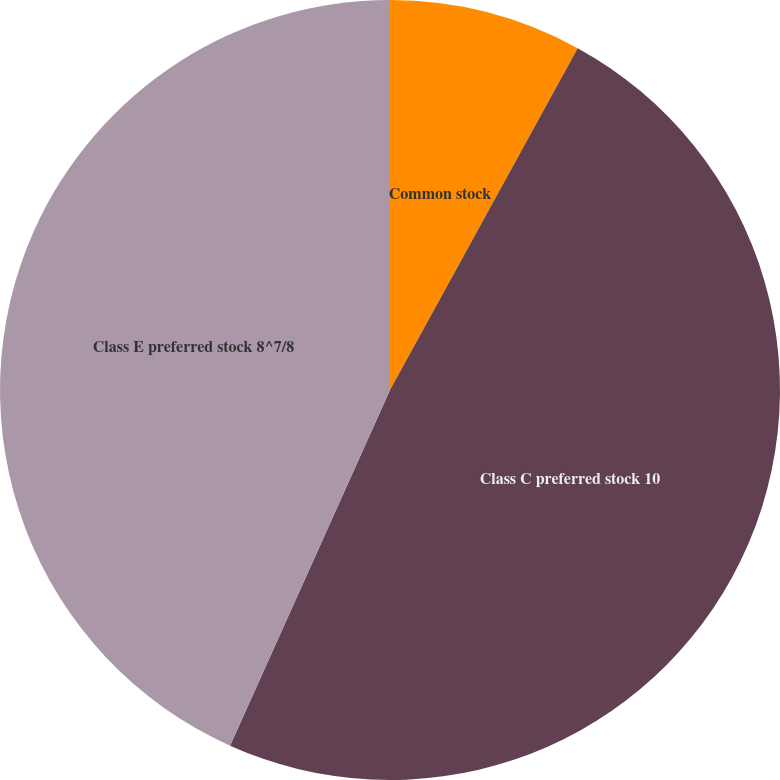Convert chart to OTSL. <chart><loc_0><loc_0><loc_500><loc_500><pie_chart><fcel>Common stock<fcel>Class C preferred stock 10<fcel>Class E preferred stock 8^7/8<nl><fcel>7.99%<fcel>48.73%<fcel>43.27%<nl></chart> 